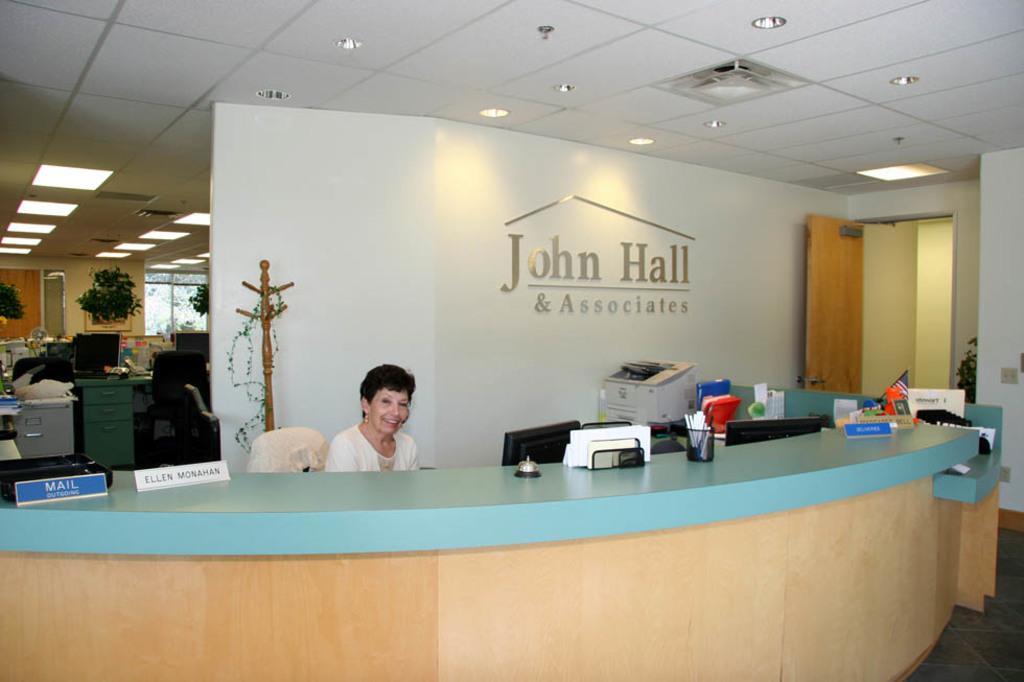Can you describe this image briefly? In the center one lady she is sitting on chair and she is smiling. In front of her we can see the table,on table we can see many objects. And back of this we can see the printing machine and we can see the door and wall,plants and some objects around her. 